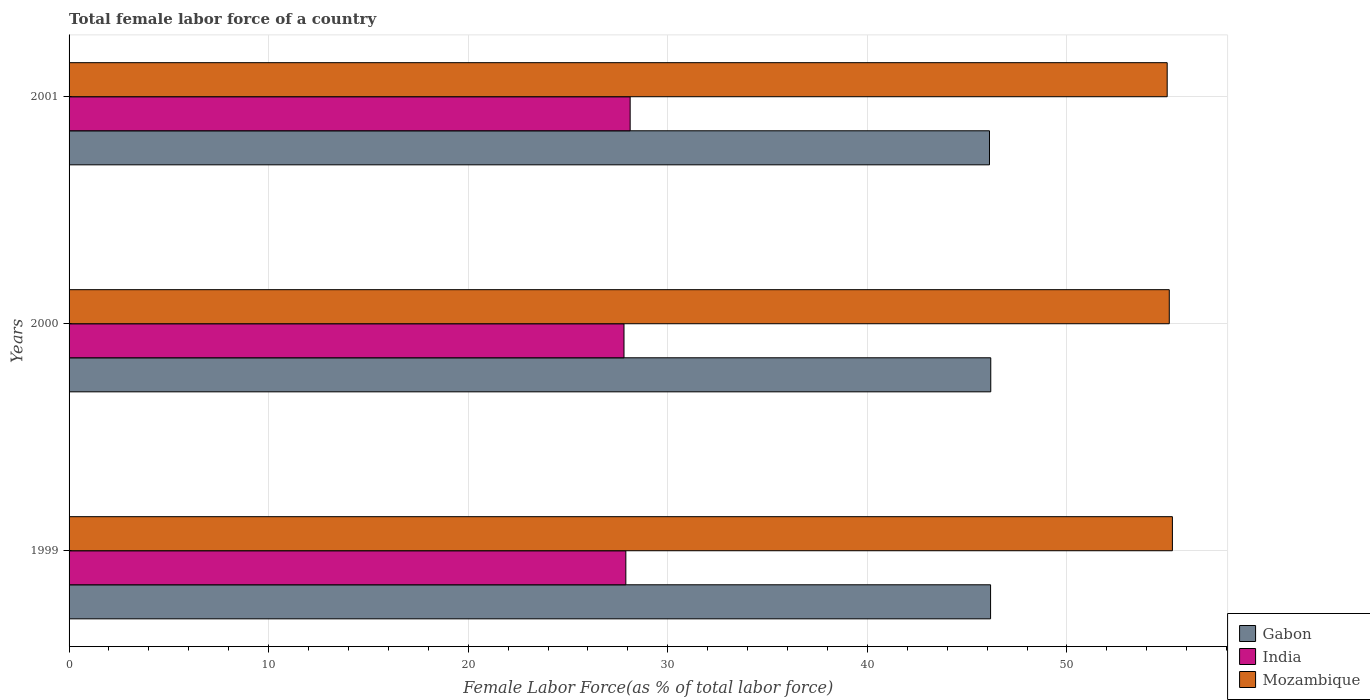How many different coloured bars are there?
Offer a very short reply. 3. How many bars are there on the 1st tick from the bottom?
Give a very brief answer. 3. What is the label of the 3rd group of bars from the top?
Give a very brief answer. 1999. In how many cases, is the number of bars for a given year not equal to the number of legend labels?
Make the answer very short. 0. What is the percentage of female labor force in Mozambique in 2000?
Your answer should be very brief. 55.13. Across all years, what is the maximum percentage of female labor force in India?
Give a very brief answer. 28.11. Across all years, what is the minimum percentage of female labor force in Mozambique?
Provide a short and direct response. 55.02. In which year was the percentage of female labor force in India maximum?
Offer a very short reply. 2001. In which year was the percentage of female labor force in India minimum?
Offer a terse response. 2000. What is the total percentage of female labor force in Gabon in the graph?
Your response must be concise. 138.47. What is the difference between the percentage of female labor force in India in 1999 and that in 2000?
Keep it short and to the point. 0.09. What is the difference between the percentage of female labor force in Mozambique in 2000 and the percentage of female labor force in Gabon in 2001?
Keep it short and to the point. 9.01. What is the average percentage of female labor force in Mozambique per year?
Keep it short and to the point. 55.14. In the year 2000, what is the difference between the percentage of female labor force in Mozambique and percentage of female labor force in India?
Provide a succinct answer. 27.32. In how many years, is the percentage of female labor force in Gabon greater than 22 %?
Keep it short and to the point. 3. What is the ratio of the percentage of female labor force in Mozambique in 1999 to that in 2001?
Provide a succinct answer. 1. Is the percentage of female labor force in India in 1999 less than that in 2000?
Provide a short and direct response. No. What is the difference between the highest and the second highest percentage of female labor force in Mozambique?
Offer a terse response. 0.16. What is the difference between the highest and the lowest percentage of female labor force in Mozambique?
Provide a short and direct response. 0.26. What does the 1st bar from the top in 1999 represents?
Give a very brief answer. Mozambique. What does the 1st bar from the bottom in 1999 represents?
Ensure brevity in your answer.  Gabon. Are all the bars in the graph horizontal?
Make the answer very short. Yes. How many years are there in the graph?
Offer a very short reply. 3. Are the values on the major ticks of X-axis written in scientific E-notation?
Give a very brief answer. No. Does the graph contain any zero values?
Keep it short and to the point. No. Where does the legend appear in the graph?
Offer a terse response. Bottom right. How are the legend labels stacked?
Keep it short and to the point. Vertical. What is the title of the graph?
Give a very brief answer. Total female labor force of a country. Does "Guyana" appear as one of the legend labels in the graph?
Make the answer very short. No. What is the label or title of the X-axis?
Ensure brevity in your answer.  Female Labor Force(as % of total labor force). What is the Female Labor Force(as % of total labor force) of Gabon in 1999?
Provide a short and direct response. 46.17. What is the Female Labor Force(as % of total labor force) in India in 1999?
Your answer should be compact. 27.9. What is the Female Labor Force(as % of total labor force) of Mozambique in 1999?
Your response must be concise. 55.28. What is the Female Labor Force(as % of total labor force) of Gabon in 2000?
Keep it short and to the point. 46.18. What is the Female Labor Force(as % of total labor force) of India in 2000?
Offer a very short reply. 27.8. What is the Female Labor Force(as % of total labor force) in Mozambique in 2000?
Provide a short and direct response. 55.13. What is the Female Labor Force(as % of total labor force) in Gabon in 2001?
Ensure brevity in your answer.  46.12. What is the Female Labor Force(as % of total labor force) of India in 2001?
Give a very brief answer. 28.11. What is the Female Labor Force(as % of total labor force) in Mozambique in 2001?
Offer a terse response. 55.02. Across all years, what is the maximum Female Labor Force(as % of total labor force) in Gabon?
Offer a terse response. 46.18. Across all years, what is the maximum Female Labor Force(as % of total labor force) of India?
Make the answer very short. 28.11. Across all years, what is the maximum Female Labor Force(as % of total labor force) of Mozambique?
Give a very brief answer. 55.28. Across all years, what is the minimum Female Labor Force(as % of total labor force) of Gabon?
Provide a short and direct response. 46.12. Across all years, what is the minimum Female Labor Force(as % of total labor force) of India?
Your answer should be compact. 27.8. Across all years, what is the minimum Female Labor Force(as % of total labor force) in Mozambique?
Offer a terse response. 55.02. What is the total Female Labor Force(as % of total labor force) in Gabon in the graph?
Make the answer very short. 138.47. What is the total Female Labor Force(as % of total labor force) of India in the graph?
Provide a succinct answer. 83.82. What is the total Female Labor Force(as % of total labor force) in Mozambique in the graph?
Provide a succinct answer. 165.43. What is the difference between the Female Labor Force(as % of total labor force) of Gabon in 1999 and that in 2000?
Offer a very short reply. -0.01. What is the difference between the Female Labor Force(as % of total labor force) of India in 1999 and that in 2000?
Keep it short and to the point. 0.09. What is the difference between the Female Labor Force(as % of total labor force) in Mozambique in 1999 and that in 2000?
Give a very brief answer. 0.16. What is the difference between the Female Labor Force(as % of total labor force) in Gabon in 1999 and that in 2001?
Give a very brief answer. 0.06. What is the difference between the Female Labor Force(as % of total labor force) in India in 1999 and that in 2001?
Your answer should be compact. -0.22. What is the difference between the Female Labor Force(as % of total labor force) in Mozambique in 1999 and that in 2001?
Your response must be concise. 0.26. What is the difference between the Female Labor Force(as % of total labor force) in Gabon in 2000 and that in 2001?
Your response must be concise. 0.06. What is the difference between the Female Labor Force(as % of total labor force) in India in 2000 and that in 2001?
Your response must be concise. -0.31. What is the difference between the Female Labor Force(as % of total labor force) of Mozambique in 2000 and that in 2001?
Your answer should be compact. 0.1. What is the difference between the Female Labor Force(as % of total labor force) in Gabon in 1999 and the Female Labor Force(as % of total labor force) in India in 2000?
Make the answer very short. 18.37. What is the difference between the Female Labor Force(as % of total labor force) in Gabon in 1999 and the Female Labor Force(as % of total labor force) in Mozambique in 2000?
Your answer should be compact. -8.95. What is the difference between the Female Labor Force(as % of total labor force) of India in 1999 and the Female Labor Force(as % of total labor force) of Mozambique in 2000?
Ensure brevity in your answer.  -27.23. What is the difference between the Female Labor Force(as % of total labor force) of Gabon in 1999 and the Female Labor Force(as % of total labor force) of India in 2001?
Ensure brevity in your answer.  18.06. What is the difference between the Female Labor Force(as % of total labor force) in Gabon in 1999 and the Female Labor Force(as % of total labor force) in Mozambique in 2001?
Make the answer very short. -8.85. What is the difference between the Female Labor Force(as % of total labor force) in India in 1999 and the Female Labor Force(as % of total labor force) in Mozambique in 2001?
Keep it short and to the point. -27.12. What is the difference between the Female Labor Force(as % of total labor force) of Gabon in 2000 and the Female Labor Force(as % of total labor force) of India in 2001?
Your answer should be compact. 18.07. What is the difference between the Female Labor Force(as % of total labor force) of Gabon in 2000 and the Female Labor Force(as % of total labor force) of Mozambique in 2001?
Your answer should be compact. -8.84. What is the difference between the Female Labor Force(as % of total labor force) in India in 2000 and the Female Labor Force(as % of total labor force) in Mozambique in 2001?
Offer a terse response. -27.22. What is the average Female Labor Force(as % of total labor force) of Gabon per year?
Provide a short and direct response. 46.16. What is the average Female Labor Force(as % of total labor force) in India per year?
Give a very brief answer. 27.94. What is the average Female Labor Force(as % of total labor force) of Mozambique per year?
Your answer should be very brief. 55.14. In the year 1999, what is the difference between the Female Labor Force(as % of total labor force) in Gabon and Female Labor Force(as % of total labor force) in India?
Your answer should be very brief. 18.28. In the year 1999, what is the difference between the Female Labor Force(as % of total labor force) in Gabon and Female Labor Force(as % of total labor force) in Mozambique?
Provide a succinct answer. -9.11. In the year 1999, what is the difference between the Female Labor Force(as % of total labor force) of India and Female Labor Force(as % of total labor force) of Mozambique?
Provide a succinct answer. -27.39. In the year 2000, what is the difference between the Female Labor Force(as % of total labor force) of Gabon and Female Labor Force(as % of total labor force) of India?
Your answer should be very brief. 18.38. In the year 2000, what is the difference between the Female Labor Force(as % of total labor force) in Gabon and Female Labor Force(as % of total labor force) in Mozambique?
Your answer should be very brief. -8.94. In the year 2000, what is the difference between the Female Labor Force(as % of total labor force) of India and Female Labor Force(as % of total labor force) of Mozambique?
Your response must be concise. -27.32. In the year 2001, what is the difference between the Female Labor Force(as % of total labor force) of Gabon and Female Labor Force(as % of total labor force) of India?
Your response must be concise. 18. In the year 2001, what is the difference between the Female Labor Force(as % of total labor force) of Gabon and Female Labor Force(as % of total labor force) of Mozambique?
Provide a succinct answer. -8.9. In the year 2001, what is the difference between the Female Labor Force(as % of total labor force) of India and Female Labor Force(as % of total labor force) of Mozambique?
Your response must be concise. -26.91. What is the ratio of the Female Labor Force(as % of total labor force) in Gabon in 1999 to that in 2000?
Your response must be concise. 1. What is the ratio of the Female Labor Force(as % of total labor force) in India in 1999 to that in 2000?
Make the answer very short. 1. What is the ratio of the Female Labor Force(as % of total labor force) in Mozambique in 1999 to that in 2000?
Your answer should be compact. 1. What is the ratio of the Female Labor Force(as % of total labor force) in Gabon in 1999 to that in 2001?
Your answer should be compact. 1. What is the ratio of the Female Labor Force(as % of total labor force) in India in 1999 to that in 2001?
Your answer should be compact. 0.99. What is the ratio of the Female Labor Force(as % of total labor force) of Mozambique in 1999 to that in 2001?
Offer a terse response. 1. What is the ratio of the Female Labor Force(as % of total labor force) of Gabon in 2000 to that in 2001?
Offer a very short reply. 1. What is the ratio of the Female Labor Force(as % of total labor force) in India in 2000 to that in 2001?
Make the answer very short. 0.99. What is the difference between the highest and the second highest Female Labor Force(as % of total labor force) in Gabon?
Provide a short and direct response. 0.01. What is the difference between the highest and the second highest Female Labor Force(as % of total labor force) of India?
Give a very brief answer. 0.22. What is the difference between the highest and the second highest Female Labor Force(as % of total labor force) in Mozambique?
Provide a short and direct response. 0.16. What is the difference between the highest and the lowest Female Labor Force(as % of total labor force) of Gabon?
Ensure brevity in your answer.  0.06. What is the difference between the highest and the lowest Female Labor Force(as % of total labor force) of India?
Give a very brief answer. 0.31. What is the difference between the highest and the lowest Female Labor Force(as % of total labor force) in Mozambique?
Keep it short and to the point. 0.26. 